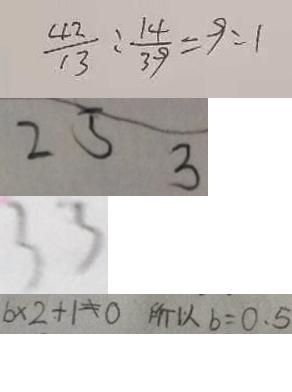Convert formula to latex. <formula><loc_0><loc_0><loc_500><loc_500>\frac { 4 2 } { 1 3 } : \frac { 1 4 } { 3 9 } = 9 : 1 
 2 5 3 
 3 3 
 b \times 2 + 1 \neq 0 所 以 b = 0 . 5</formula> 